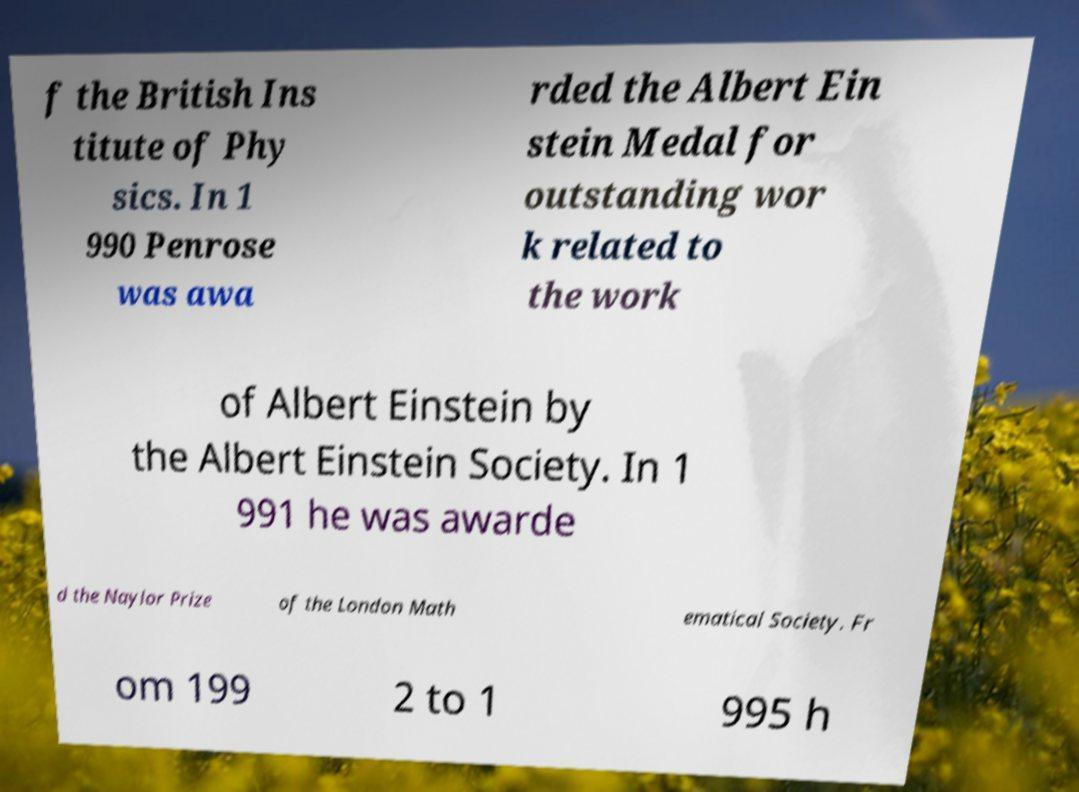Can you read and provide the text displayed in the image?This photo seems to have some interesting text. Can you extract and type it out for me? f the British Ins titute of Phy sics. In 1 990 Penrose was awa rded the Albert Ein stein Medal for outstanding wor k related to the work of Albert Einstein by the Albert Einstein Society. In 1 991 he was awarde d the Naylor Prize of the London Math ematical Society. Fr om 199 2 to 1 995 h 